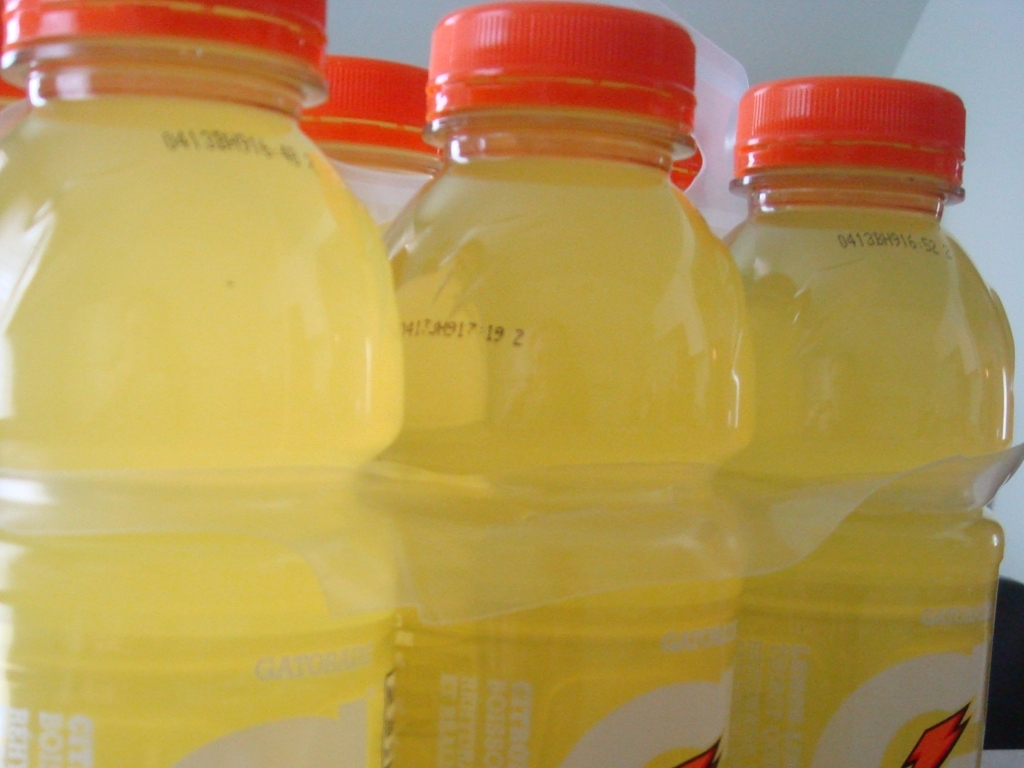What can you tell about the lighting conditions in this photograph? The lighting in the photograph is diffused, creating soft shadows and avoiding harsh highlights. This is indicative of indoor photography, possibly using natural light from a nearby window or ambient artificial lighting. 